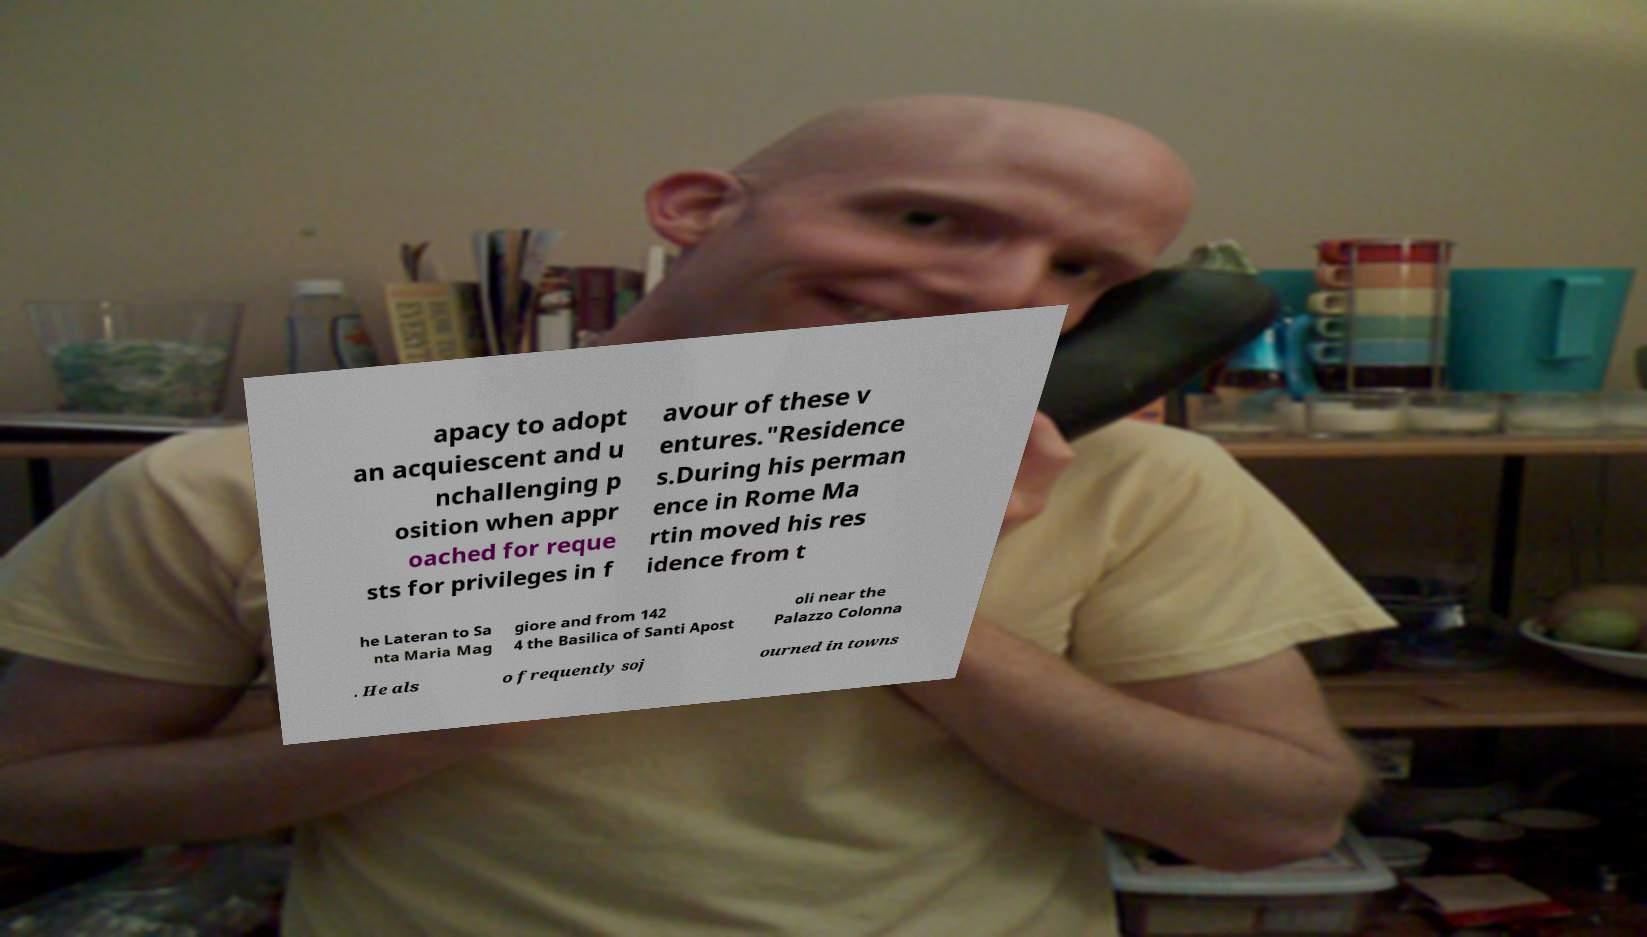I need the written content from this picture converted into text. Can you do that? apacy to adopt an acquiescent and u nchallenging p osition when appr oached for reque sts for privileges in f avour of these v entures."Residence s.During his perman ence in Rome Ma rtin moved his res idence from t he Lateran to Sa nta Maria Mag giore and from 142 4 the Basilica of Santi Apost oli near the Palazzo Colonna . He als o frequently soj ourned in towns 